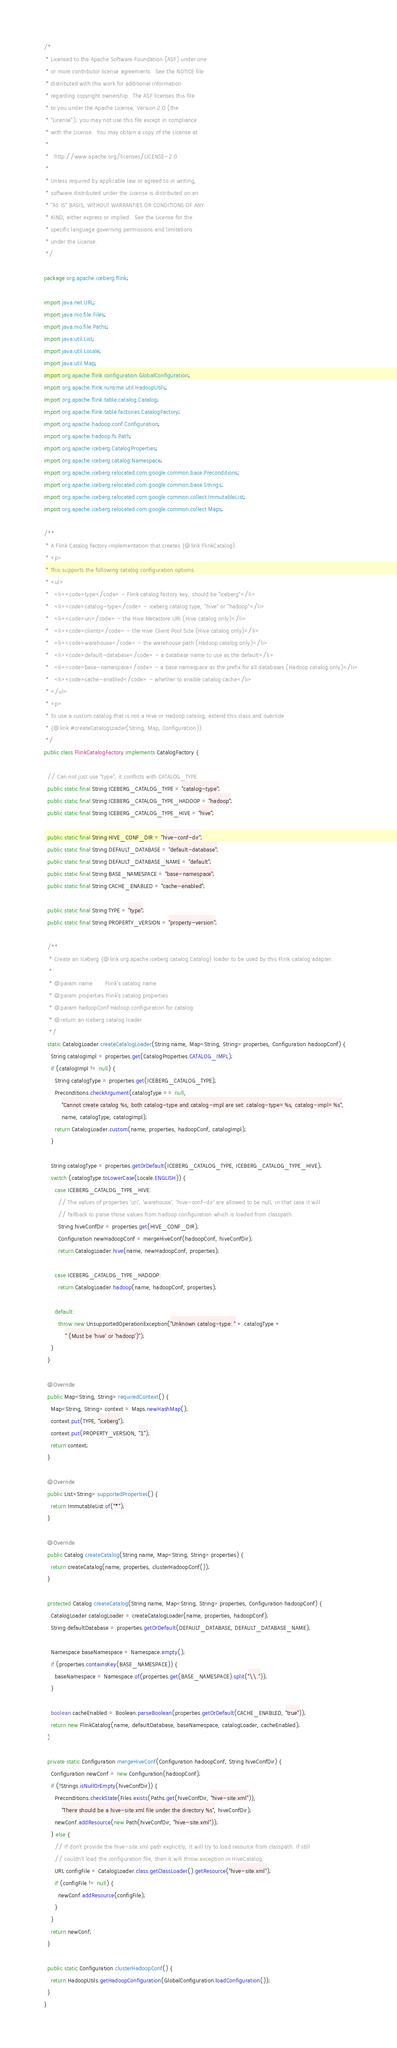<code> <loc_0><loc_0><loc_500><loc_500><_Java_>/*
 * Licensed to the Apache Software Foundation (ASF) under one
 * or more contributor license agreements.  See the NOTICE file
 * distributed with this work for additional information
 * regarding copyright ownership.  The ASF licenses this file
 * to you under the Apache License, Version 2.0 (the
 * "License"); you may not use this file except in compliance
 * with the License.  You may obtain a copy of the License at
 *
 *   http://www.apache.org/licenses/LICENSE-2.0
 *
 * Unless required by applicable law or agreed to in writing,
 * software distributed under the License is distributed on an
 * "AS IS" BASIS, WITHOUT WARRANTIES OR CONDITIONS OF ANY
 * KIND, either express or implied.  See the License for the
 * specific language governing permissions and limitations
 * under the License.
 */

package org.apache.iceberg.flink;

import java.net.URL;
import java.nio.file.Files;
import java.nio.file.Paths;
import java.util.List;
import java.util.Locale;
import java.util.Map;
import org.apache.flink.configuration.GlobalConfiguration;
import org.apache.flink.runtime.util.HadoopUtils;
import org.apache.flink.table.catalog.Catalog;
import org.apache.flink.table.factories.CatalogFactory;
import org.apache.hadoop.conf.Configuration;
import org.apache.hadoop.fs.Path;
import org.apache.iceberg.CatalogProperties;
import org.apache.iceberg.catalog.Namespace;
import org.apache.iceberg.relocated.com.google.common.base.Preconditions;
import org.apache.iceberg.relocated.com.google.common.base.Strings;
import org.apache.iceberg.relocated.com.google.common.collect.ImmutableList;
import org.apache.iceberg.relocated.com.google.common.collect.Maps;

/**
 * A Flink Catalog factory implementation that creates {@link FlinkCatalog}.
 * <p>
 * This supports the following catalog configuration options:
 * <ul>
 *   <li><code>type</code> - Flink catalog factory key, should be "iceberg"</li>
 *   <li><code>catalog-type</code> - iceberg catalog type, "hive" or "hadoop"</li>
 *   <li><code>uri</code> - the Hive Metastore URI (Hive catalog only)</li>
 *   <li><code>clients</code> - the Hive Client Pool Size (Hive catalog only)</li>
 *   <li><code>warehouse</code> - the warehouse path (Hadoop catalog only)</li>
 *   <li><code>default-database</code> - a database name to use as the default</li>
 *   <li><code>base-namespace</code> - a base namespace as the prefix for all databases (Hadoop catalog only)</li>
 *   <li><code>cache-enabled</code> - whether to enable catalog cache</li>
 * </ul>
 * <p>
 * To use a custom catalog that is not a Hive or Hadoop catalog, extend this class and override
 * {@link #createCatalogLoader(String, Map, Configuration)}.
 */
public class FlinkCatalogFactory implements CatalogFactory {

  // Can not just use "type", it conflicts with CATALOG_TYPE.
  public static final String ICEBERG_CATALOG_TYPE = "catalog-type";
  public static final String ICEBERG_CATALOG_TYPE_HADOOP = "hadoop";
  public static final String ICEBERG_CATALOG_TYPE_HIVE = "hive";

  public static final String HIVE_CONF_DIR = "hive-conf-dir";
  public static final String DEFAULT_DATABASE = "default-database";
  public static final String DEFAULT_DATABASE_NAME = "default";
  public static final String BASE_NAMESPACE = "base-namespace";
  public static final String CACHE_ENABLED = "cache-enabled";

  public static final String TYPE = "type";
  public static final String PROPERTY_VERSION = "property-version";

  /**
   * Create an Iceberg {@link org.apache.iceberg.catalog.Catalog} loader to be used by this Flink catalog adapter.
   *
   * @param name       Flink's catalog name
   * @param properties Flink's catalog properties
   * @param hadoopConf Hadoop configuration for catalog
   * @return an Iceberg catalog loader
   */
  static CatalogLoader createCatalogLoader(String name, Map<String, String> properties, Configuration hadoopConf) {
    String catalogImpl = properties.get(CatalogProperties.CATALOG_IMPL);
    if (catalogImpl != null) {
      String catalogType = properties.get(ICEBERG_CATALOG_TYPE);
      Preconditions.checkArgument(catalogType == null,
          "Cannot create catalog %s, both catalog-type and catalog-impl are set: catalog-type=%s, catalog-impl=%s",
          name, catalogType, catalogImpl);
      return CatalogLoader.custom(name, properties, hadoopConf, catalogImpl);
    }

    String catalogType = properties.getOrDefault(ICEBERG_CATALOG_TYPE, ICEBERG_CATALOG_TYPE_HIVE);
    switch (catalogType.toLowerCase(Locale.ENGLISH)) {
      case ICEBERG_CATALOG_TYPE_HIVE:
        // The values of properties 'uri', 'warehouse', 'hive-conf-dir' are allowed to be null, in that case it will
        // fallback to parse those values from hadoop configuration which is loaded from classpath.
        String hiveConfDir = properties.get(HIVE_CONF_DIR);
        Configuration newHadoopConf = mergeHiveConf(hadoopConf, hiveConfDir);
        return CatalogLoader.hive(name, newHadoopConf, properties);

      case ICEBERG_CATALOG_TYPE_HADOOP:
        return CatalogLoader.hadoop(name, hadoopConf, properties);

      default:
        throw new UnsupportedOperationException("Unknown catalog-type: " + catalogType +
            " (Must be 'hive' or 'hadoop')");
    }
  }

  @Override
  public Map<String, String> requiredContext() {
    Map<String, String> context = Maps.newHashMap();
    context.put(TYPE, "iceberg");
    context.put(PROPERTY_VERSION, "1");
    return context;
  }

  @Override
  public List<String> supportedProperties() {
    return ImmutableList.of("*");
  }

  @Override
  public Catalog createCatalog(String name, Map<String, String> properties) {
    return createCatalog(name, properties, clusterHadoopConf());
  }

  protected Catalog createCatalog(String name, Map<String, String> properties, Configuration hadoopConf) {
    CatalogLoader catalogLoader = createCatalogLoader(name, properties, hadoopConf);
    String defaultDatabase = properties.getOrDefault(DEFAULT_DATABASE, DEFAULT_DATABASE_NAME);

    Namespace baseNamespace = Namespace.empty();
    if (properties.containsKey(BASE_NAMESPACE)) {
      baseNamespace = Namespace.of(properties.get(BASE_NAMESPACE).split("\\."));
    }

    boolean cacheEnabled = Boolean.parseBoolean(properties.getOrDefault(CACHE_ENABLED, "true"));
    return new FlinkCatalog(name, defaultDatabase, baseNamespace, catalogLoader, cacheEnabled);
  }

  private static Configuration mergeHiveConf(Configuration hadoopConf, String hiveConfDir) {
    Configuration newConf = new Configuration(hadoopConf);
    if (!Strings.isNullOrEmpty(hiveConfDir)) {
      Preconditions.checkState(Files.exists(Paths.get(hiveConfDir, "hive-site.xml")),
          "There should be a hive-site.xml file under the directory %s", hiveConfDir);
      newConf.addResource(new Path(hiveConfDir, "hive-site.xml"));
    } else {
      // If don't provide the hive-site.xml path explicitly, it will try to load resource from classpath. If still
      // couldn't load the configuration file, then it will throw exception in HiveCatalog.
      URL configFile = CatalogLoader.class.getClassLoader().getResource("hive-site.xml");
      if (configFile != null) {
        newConf.addResource(configFile);
      }
    }
    return newConf;
  }

  public static Configuration clusterHadoopConf() {
    return HadoopUtils.getHadoopConfiguration(GlobalConfiguration.loadConfiguration());
  }
}
</code> 